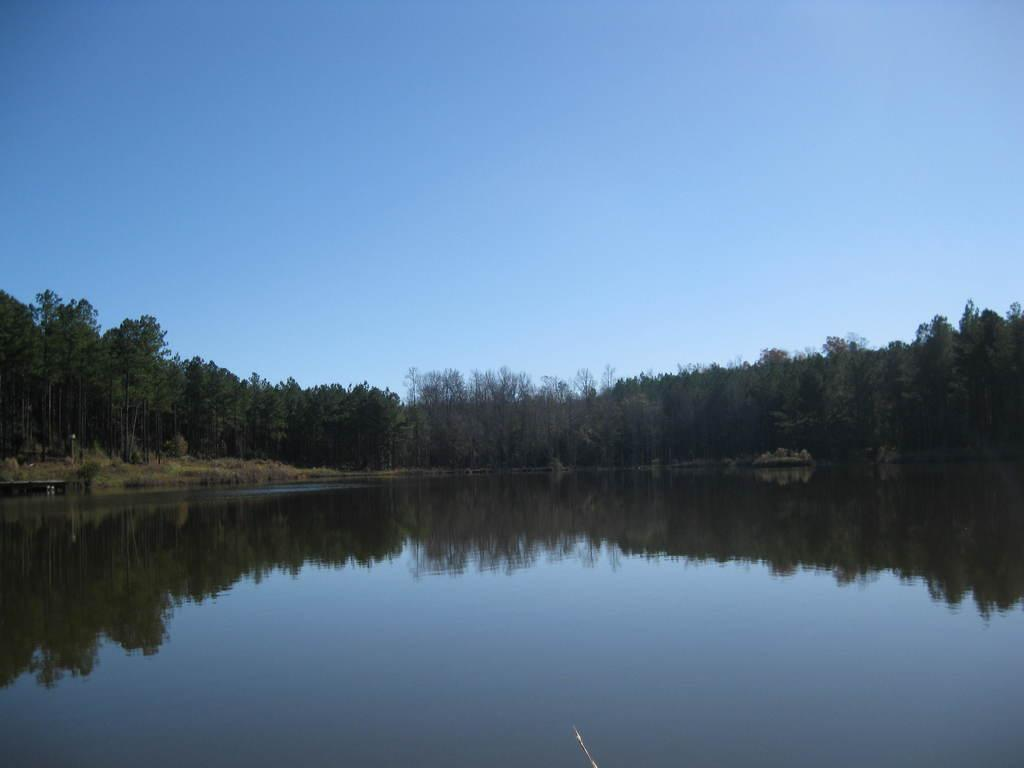What is the primary element visible in the image? There is water in the image. What can be seen in the distance in the image? There are trees in the background of the image. What is visible at the top of the image? The sky is visible at the top of the image. How many flowers are visible in the image? There are no flowers present in the image. What type of neck accessory is the person wearing in the image? There is no person or neck accessory visible in the image. 